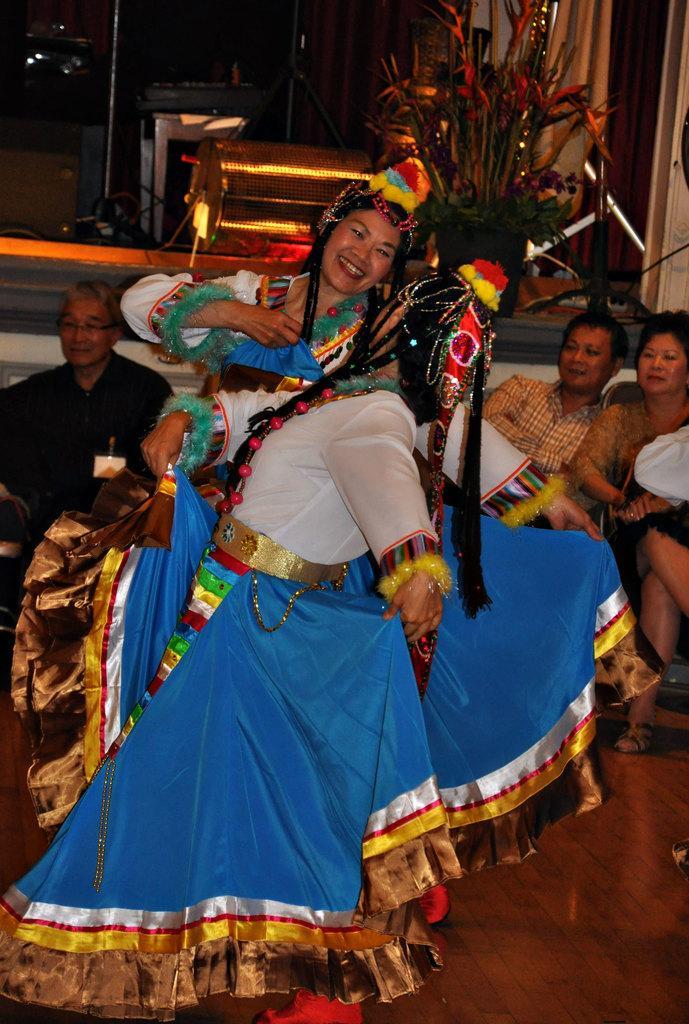Can you describe this image briefly? In this picture there are two persons dancing and wore costumes, behind two persons there are people sitting and we can see floor. In the background of the image we can see house plant and objects. 